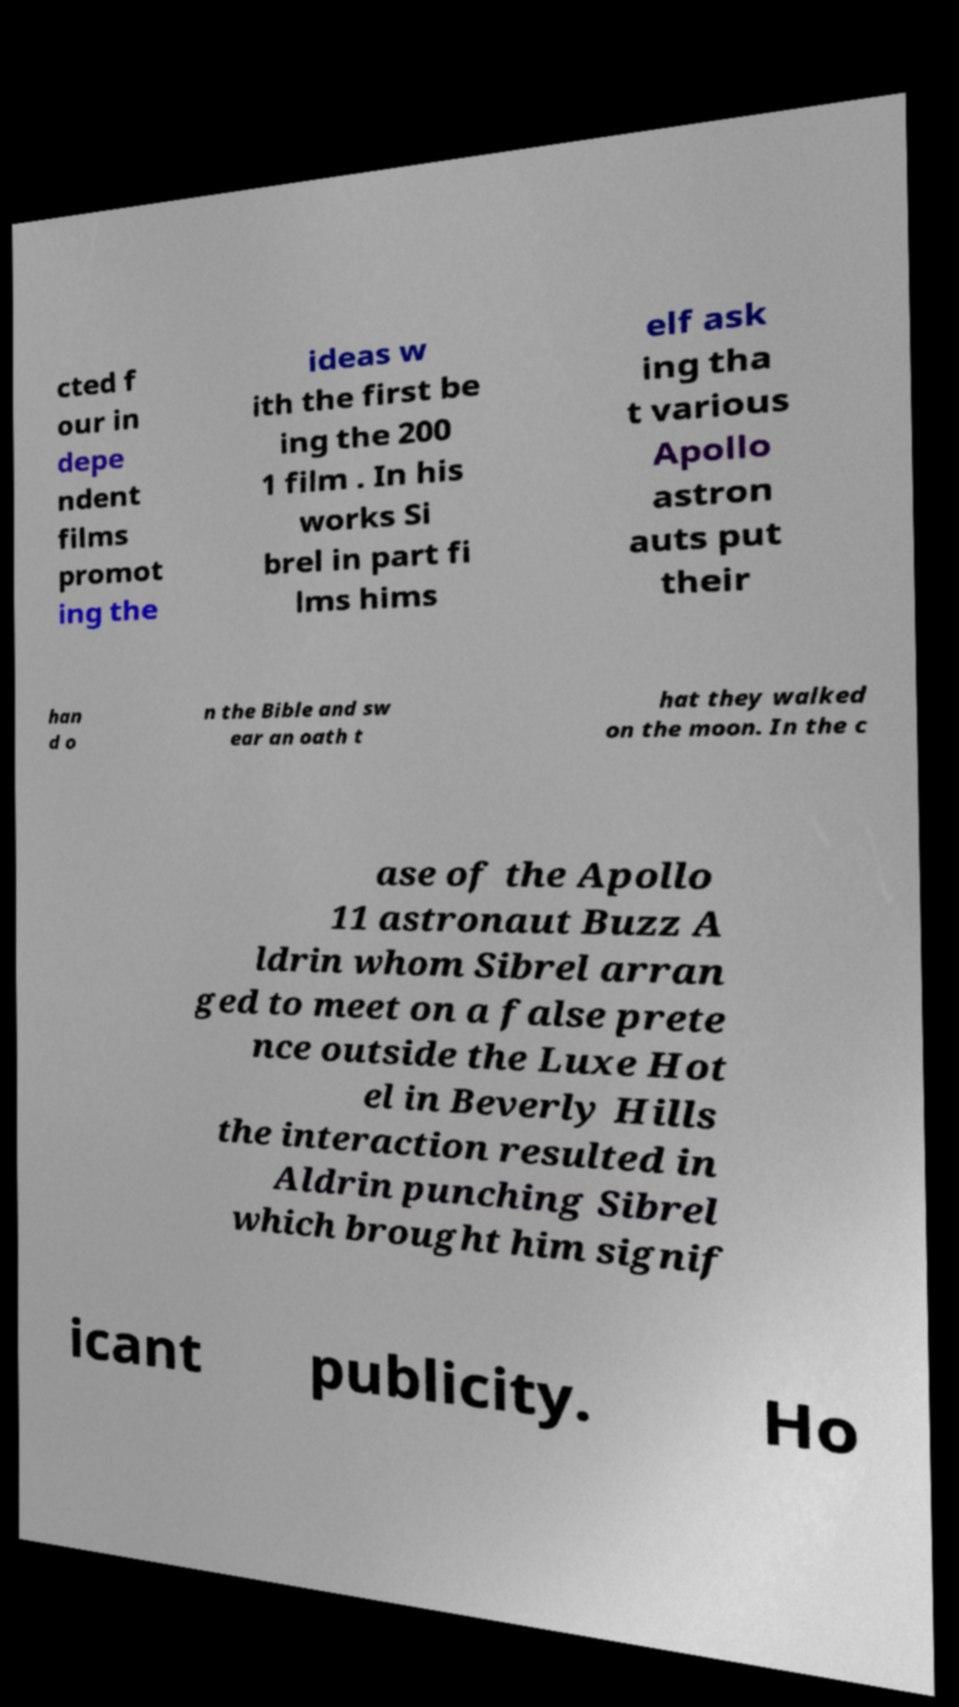Can you read and provide the text displayed in the image?This photo seems to have some interesting text. Can you extract and type it out for me? cted f our in depe ndent films promot ing the ideas w ith the first be ing the 200 1 film . In his works Si brel in part fi lms hims elf ask ing tha t various Apollo astron auts put their han d o n the Bible and sw ear an oath t hat they walked on the moon. In the c ase of the Apollo 11 astronaut Buzz A ldrin whom Sibrel arran ged to meet on a false prete nce outside the Luxe Hot el in Beverly Hills the interaction resulted in Aldrin punching Sibrel which brought him signif icant publicity. Ho 